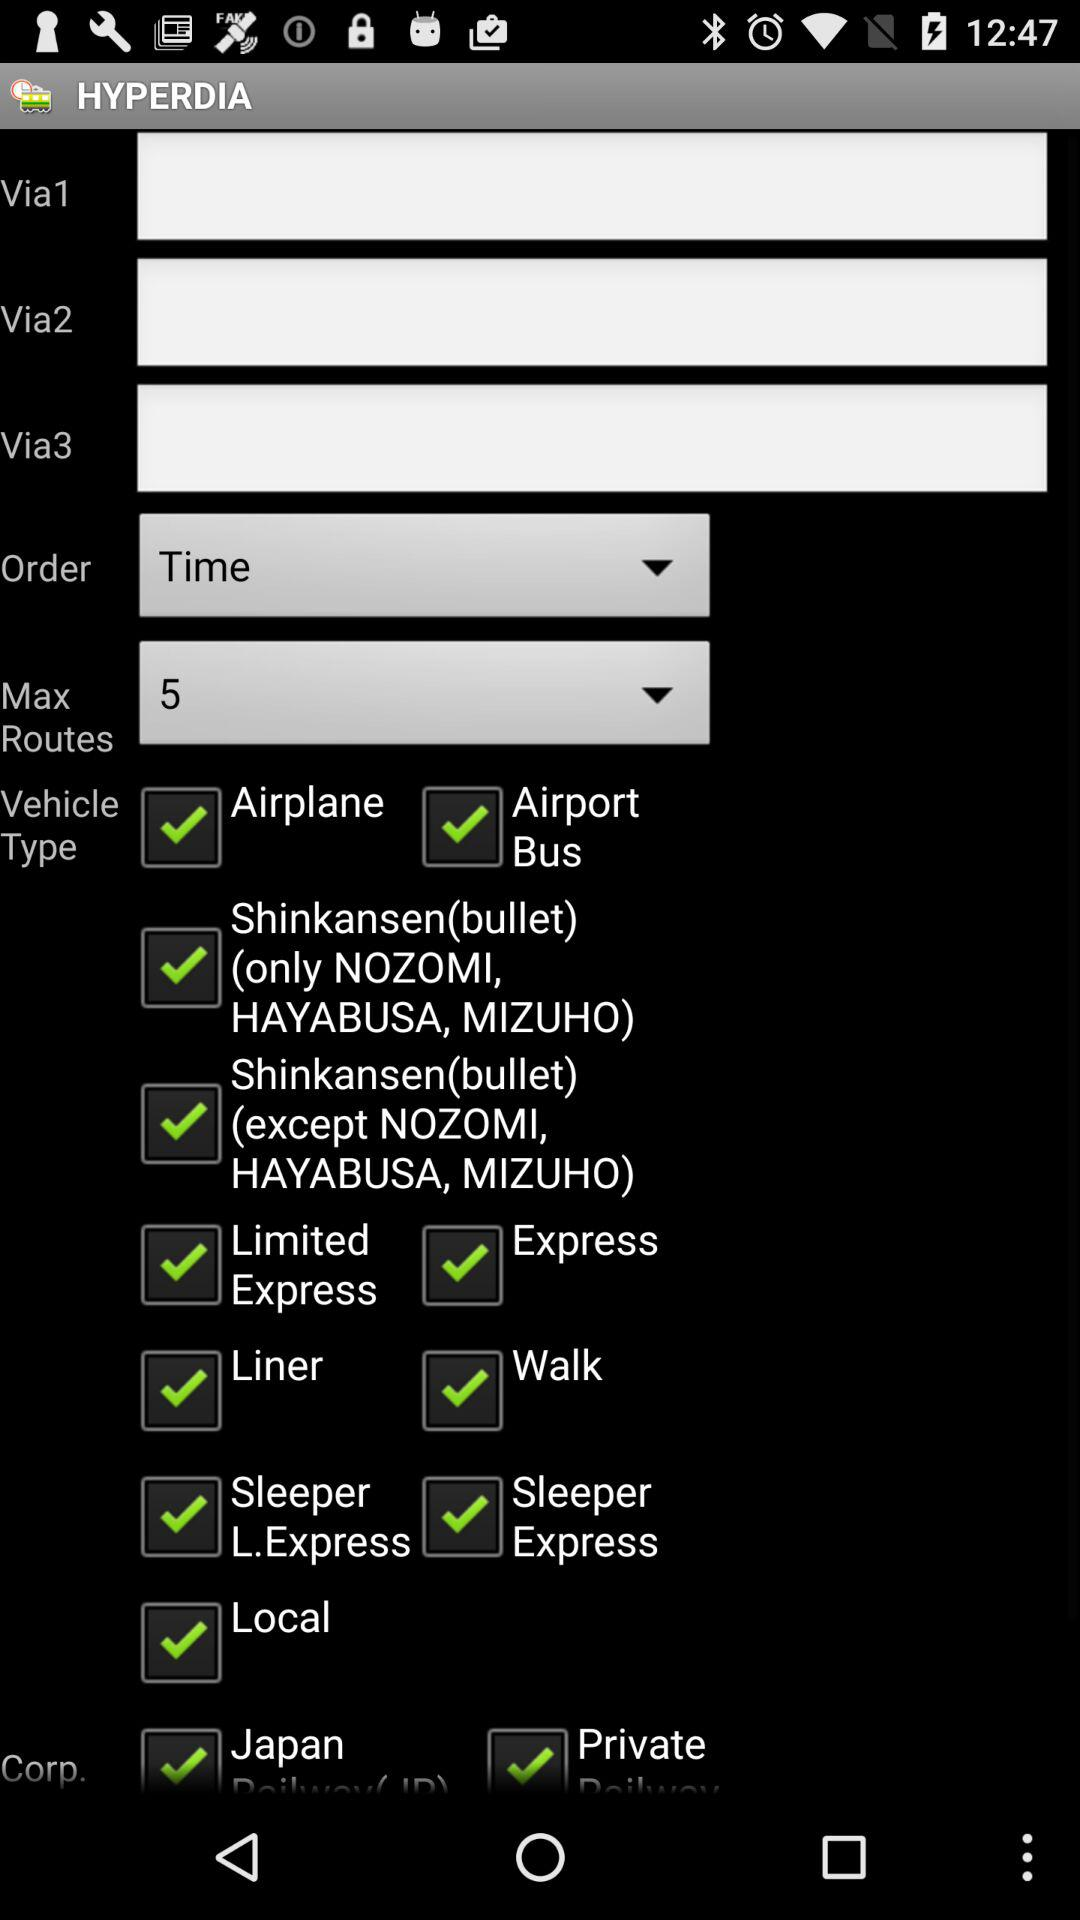What is the value of "Via1"?
When the provided information is insufficient, respond with <no answer>. <no answer> 